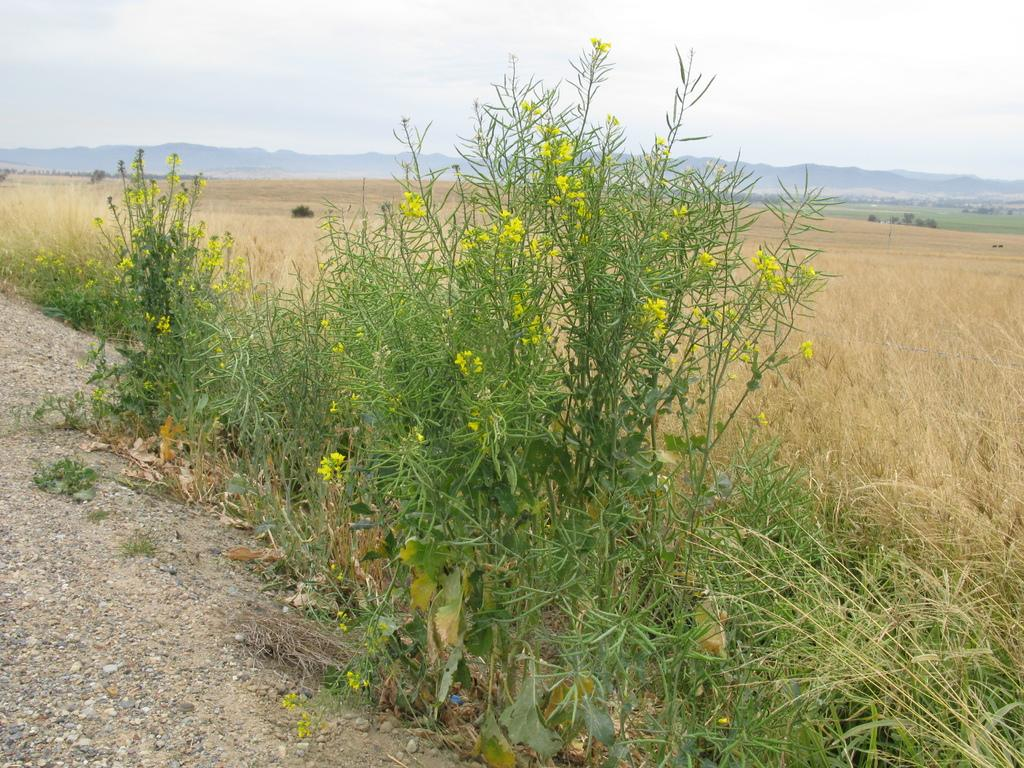What type of vegetation can be seen in the image? There are plants and flowers in the image. What is the ground covered with behind the plants? There is grass visible behind the plants. What can be seen in the distance in the image? There are mountains in the background of the image. What is visible at the top of the image? The sky is visible at the top of the image. What type of wax is being used to create the library in the image? There is no library or wax present in the image. How does the cough sound coming from the mountains in the image? There is no cough or sound present in the image; it features plants, flowers, grass, mountains, and the sky. 